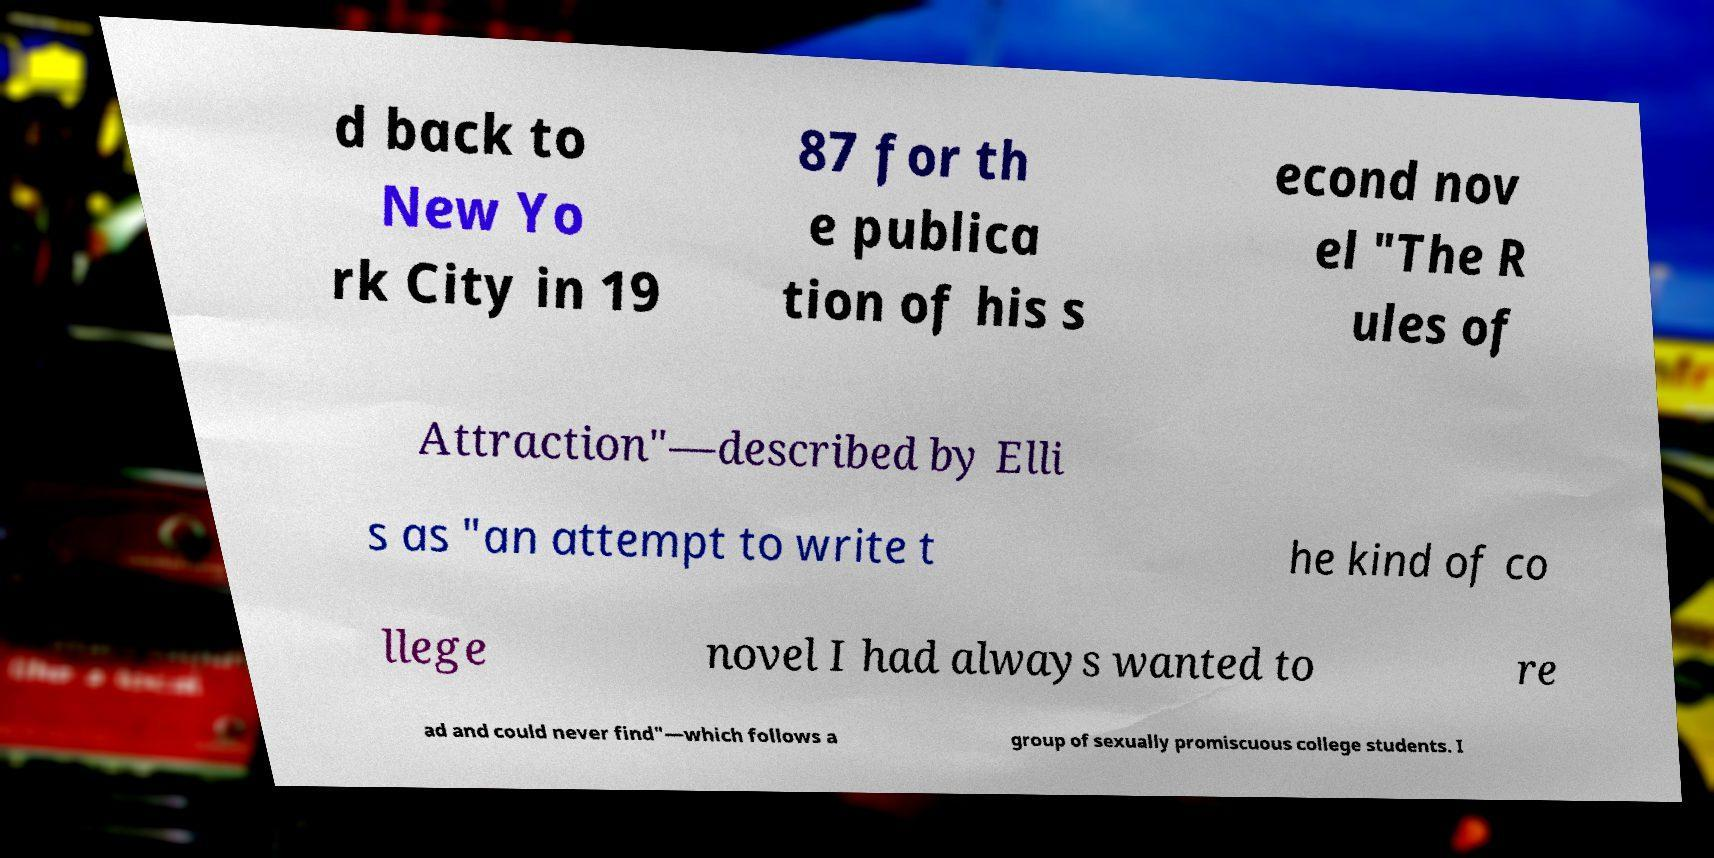Please identify and transcribe the text found in this image. d back to New Yo rk City in 19 87 for th e publica tion of his s econd nov el "The R ules of Attraction"—described by Elli s as "an attempt to write t he kind of co llege novel I had always wanted to re ad and could never find"—which follows a group of sexually promiscuous college students. I 